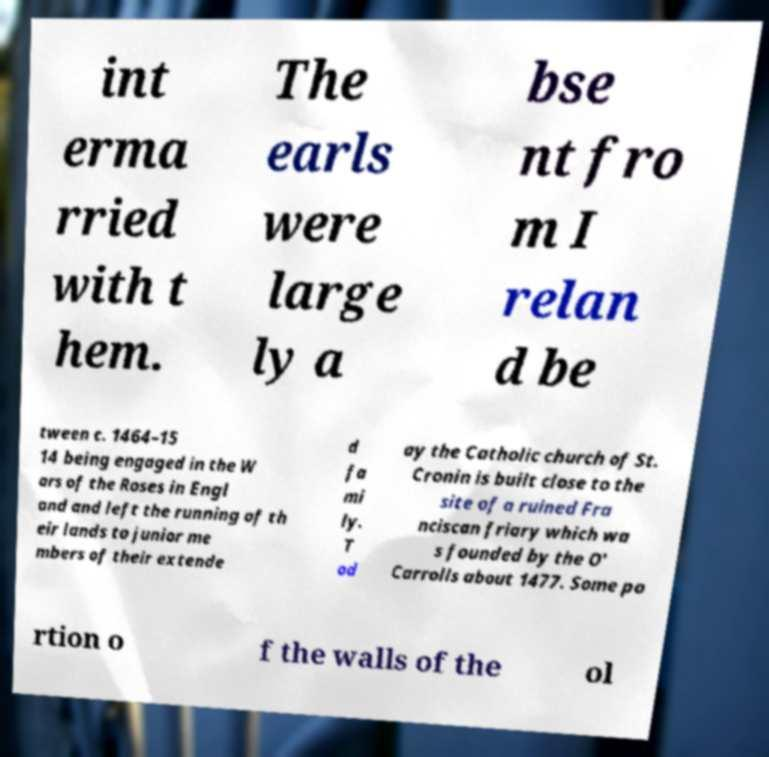Please identify and transcribe the text found in this image. int erma rried with t hem. The earls were large ly a bse nt fro m I relan d be tween c. 1464–15 14 being engaged in the W ars of the Roses in Engl and and left the running of th eir lands to junior me mbers of their extende d fa mi ly. T od ay the Catholic church of St. Cronin is built close to the site of a ruined Fra nciscan friary which wa s founded by the O' Carrolls about 1477. Some po rtion o f the walls of the ol 